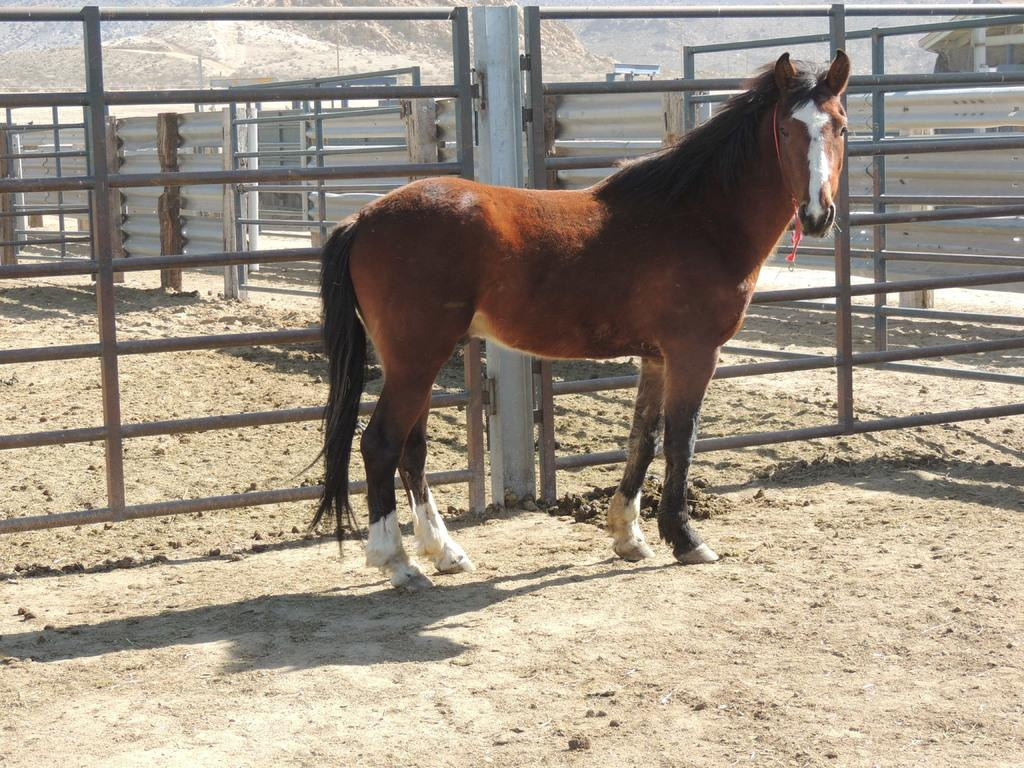What type of animal is in the image? There is a brown color horse in the image. Where is the horse located in the image? The horse is in the middle of the image. What other objects are in the middle of the image? There are iron grills in the middle of the image. What is the texture of the bottom of the image? The bottom of the image contains sand. Can you see a tiger playing with a pipe in the image? There is no tiger or pipe in the image; it features a brown color horse and iron grills. What type of grass is growing near the horse in the image? There is no grass visible in the image; it contains a horse, iron grills, and sand. 